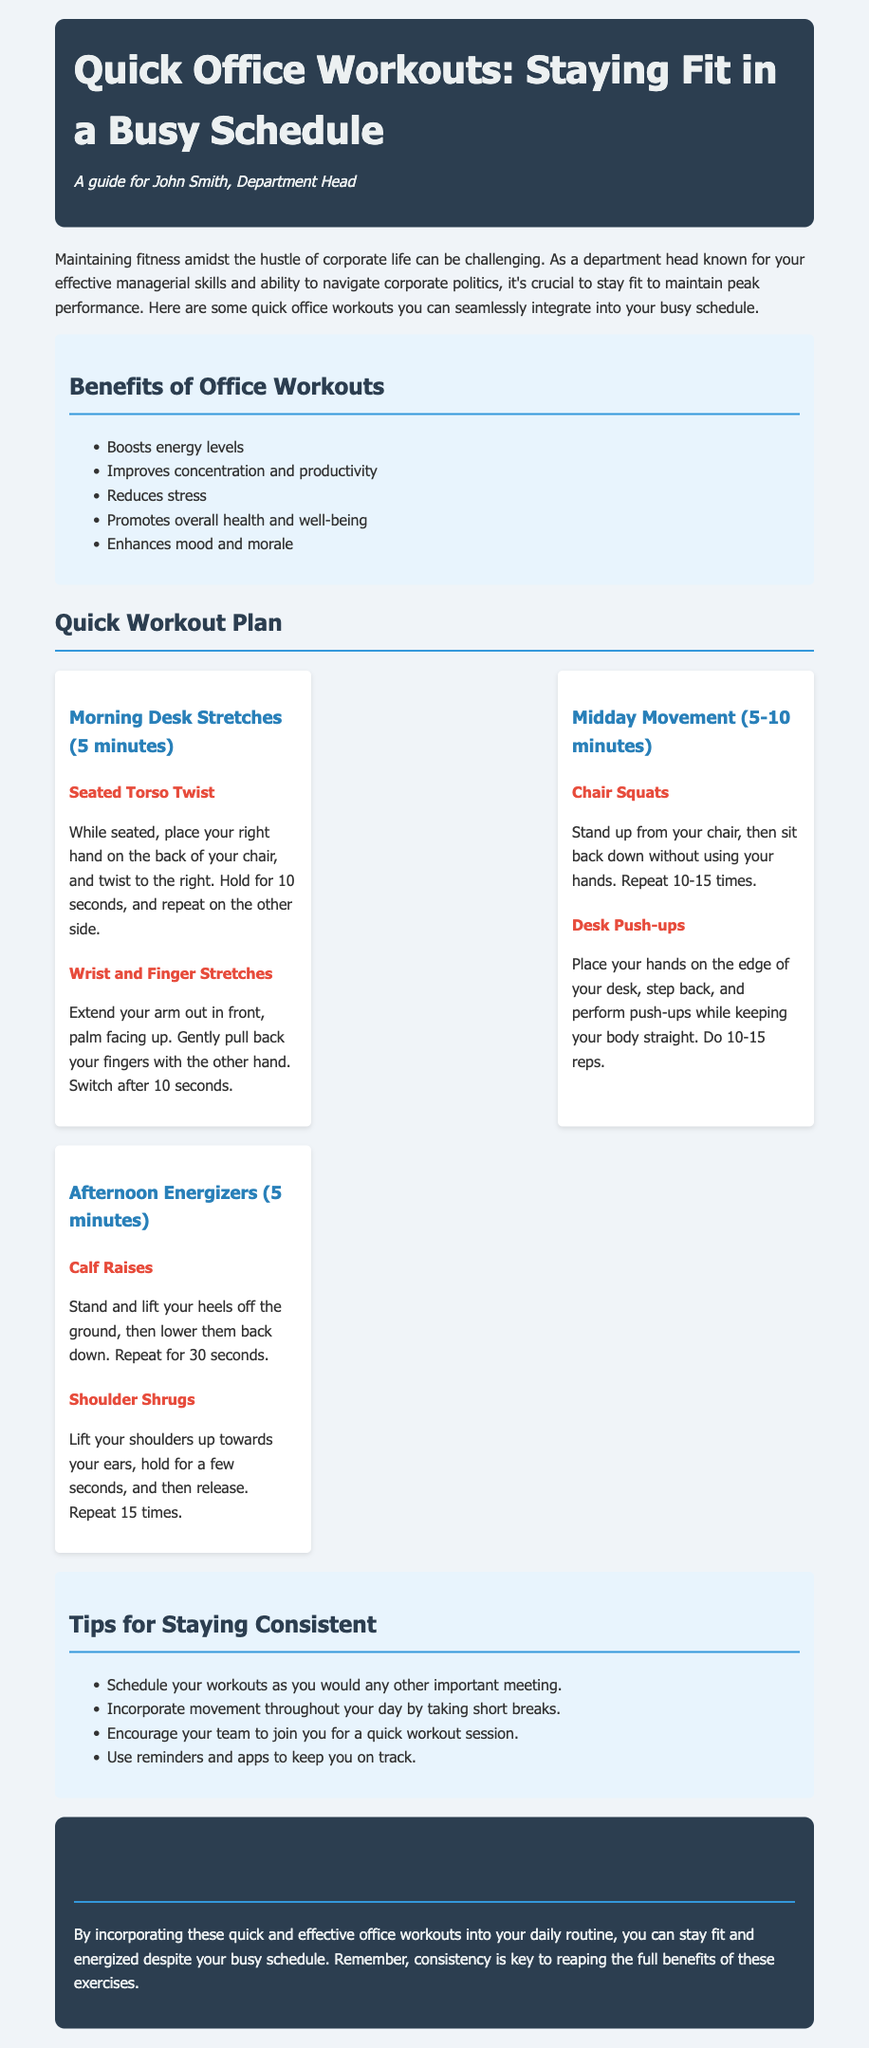What are the benefits of office workouts? The document lists several benefits of office workouts, such as boosting energy levels and improving concentration.
Answer: Boosts energy levels, Improves concentration and productivity, Reduces stress, Promotes overall health and well-being, Enhances mood and morale How long should the Morning Desk Stretches take? The document specifies that the Morning Desk Stretches take about 5 minutes.
Answer: 5 minutes What is one of the exercises in the Afternoon Energizers? Including specific examples from the Afternoon Energizers section, an exercise listed is Calf Raises.
Answer: Calf Raises How many Chair Squats are recommended? The document advises to repeat Chair Squats 10-15 times.
Answer: 10-15 times What is a tip for staying consistent with workouts? The document provides a tip to encourage scheduling workouts like important meetings.
Answer: Schedule your workouts as you would any other important meeting What type of stretching is suggested in the Morning Desk Stretches? The document suggests Seated Torso Twist as a type of stretching exercise.
Answer: Seated Torso Twist What should you do during Midday Movement? The document recommends exercises like Chair Squats and Desk Push-ups during Midday Movement.
Answer: Chair Squats, Desk Push-ups How often should the Shoulder Shrugs be repeated? The document indicates that Shoulder Shrugs should be repeated 15 times.
Answer: 15 times 